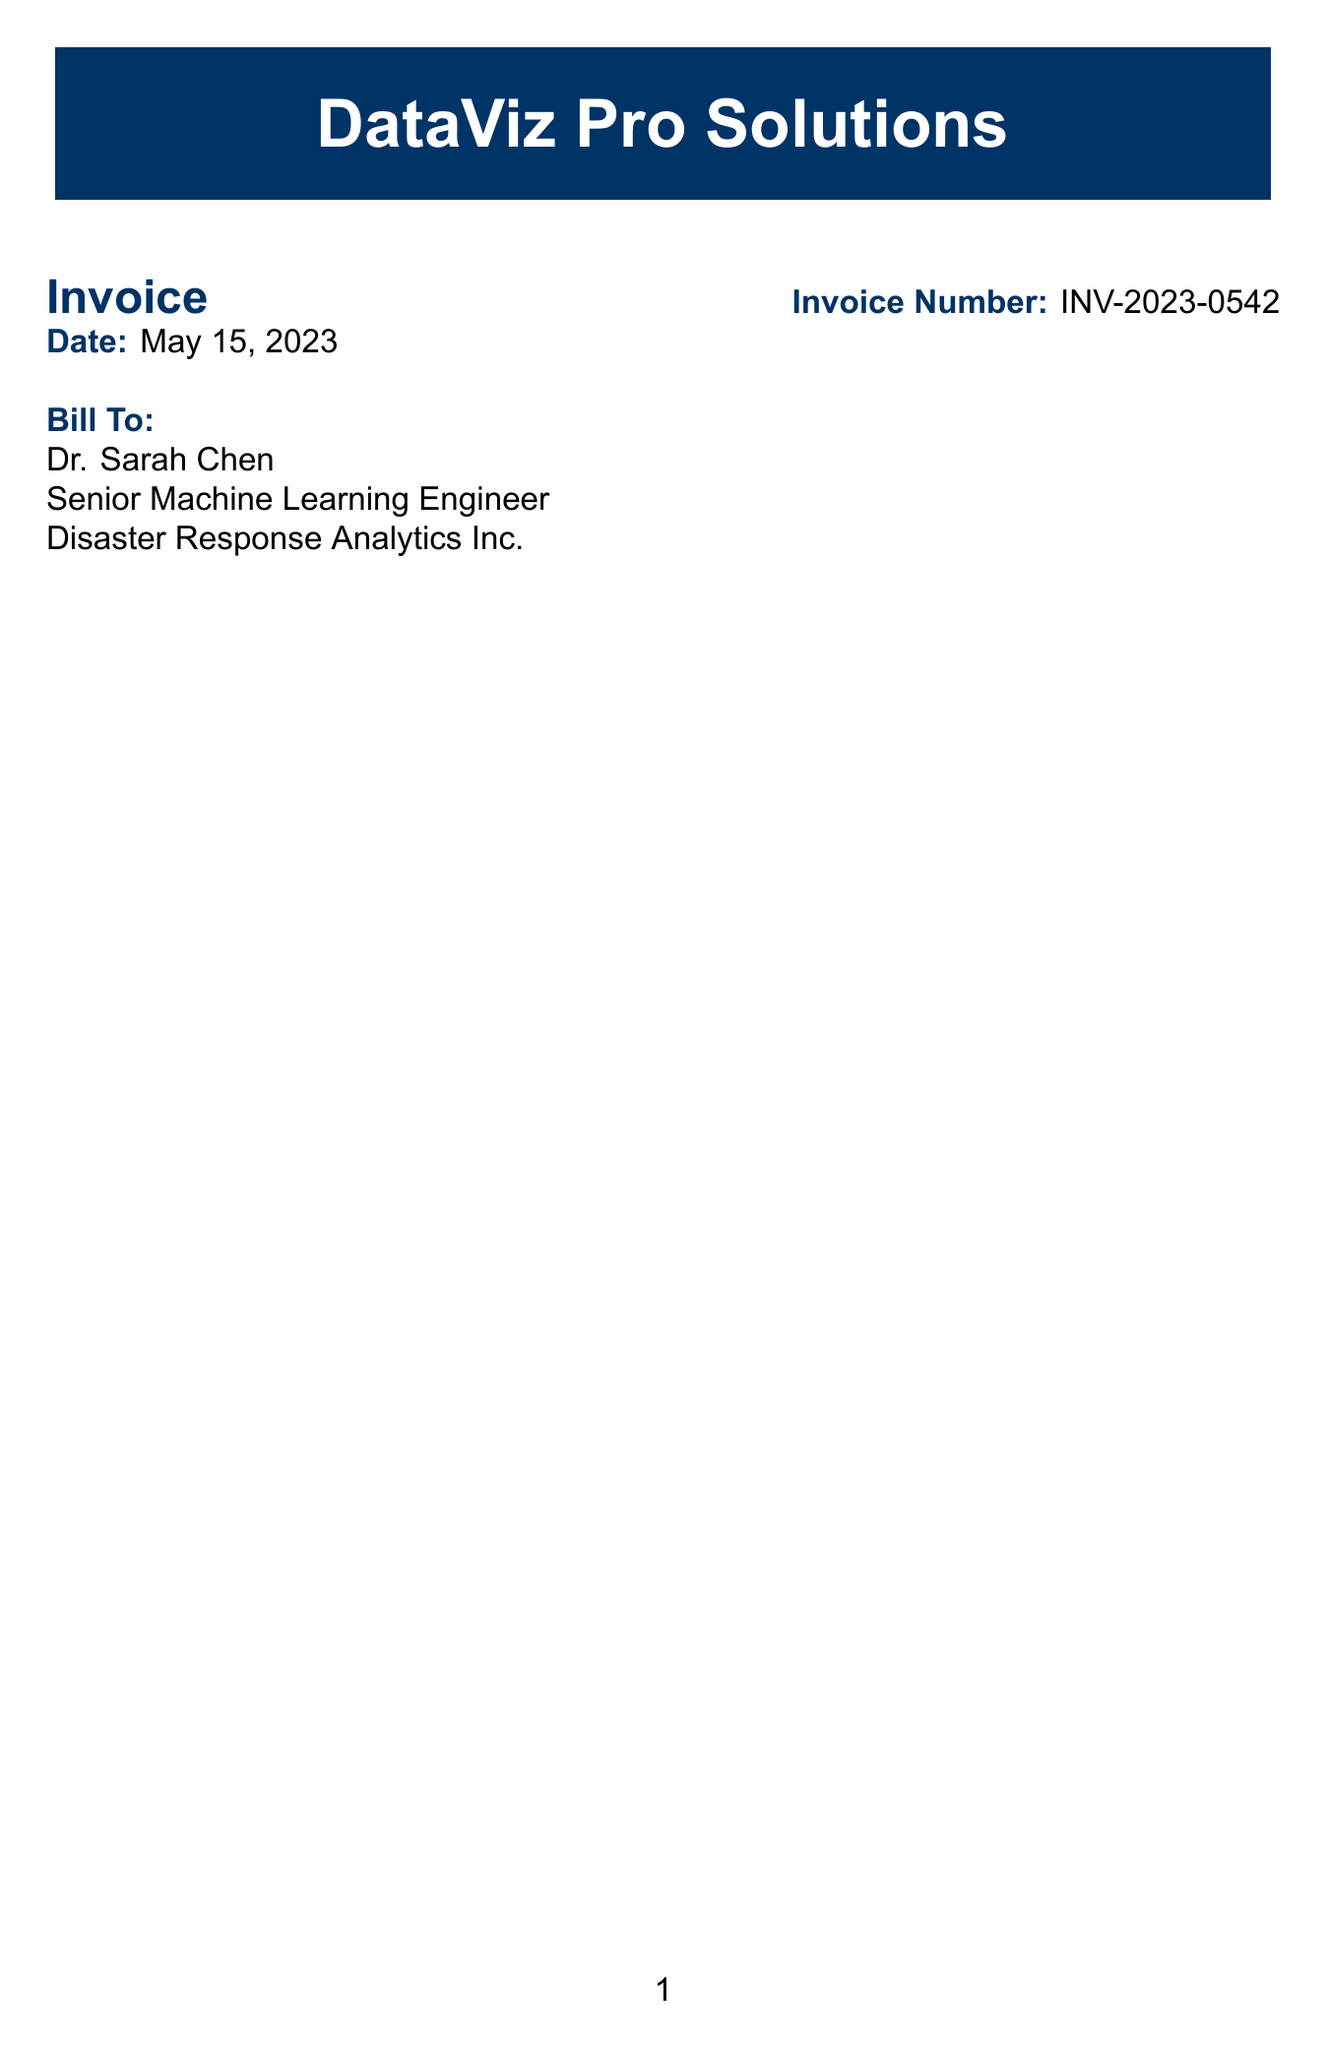What is the invoice number? The invoice number is a unique identifier for the receipt, listed prominently in the document.
Answer: INV-2023-0542 How many Tableau Desktop Professional licenses were purchased? The quantity of Tableau Desktop Professional licenses is specified under the items section of the receipt.
Answer: 2 What is the total amount before tax? The subtotal is calculated before tax and displayed in the document as part of the total cost breakdown.
Answer: 8138.98 Who is the customer company? The customer company name is listed in the billing section, providing context for the transaction.
Answer: Disaster Response Analytics Inc What features are included in the Power BI Pro license? The features included in the Power BI Pro license can be found in the description section for that specific item in the document.
Answer: Customizable dashboards, Natural language queries, Embedded analytics, Collaboration tools What is the tax rate applied on the subtotal? The tax rate is mentioned in the breakdown of charges, signifying the percentage added to the subtotal.
Answer: 8% What is the total cost including tax? The total is specified at the bottom of the receipt, representing the final amount payable.
Answer: 8790.10 What is the purpose of the licenses purchased? The purpose of the licenses is outlined in the notes section of the document, providing insight into their intended use.
Answer: Disaster data analysis and pattern recognition projects What payment terms are specified in the document? The payment terms are clearly stated in the receipt, indicating how long the customer has to make the payment.
Answer: Net 30 